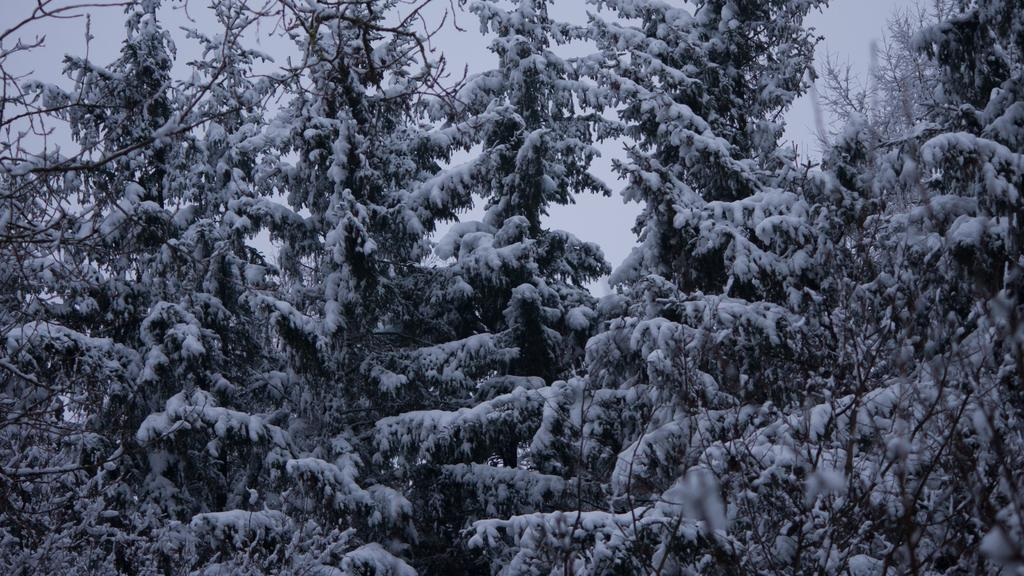What is the color scheme of the image? The image is black and white. What type of natural environment is depicted in the image? There are trees with snow in the image. What can be seen in the background of the image? The sky is visible in the background of the image. What type of bird is sitting on the throne in the image? There is no bird or throne present in the image; it features trees with snow and a visible sky. 